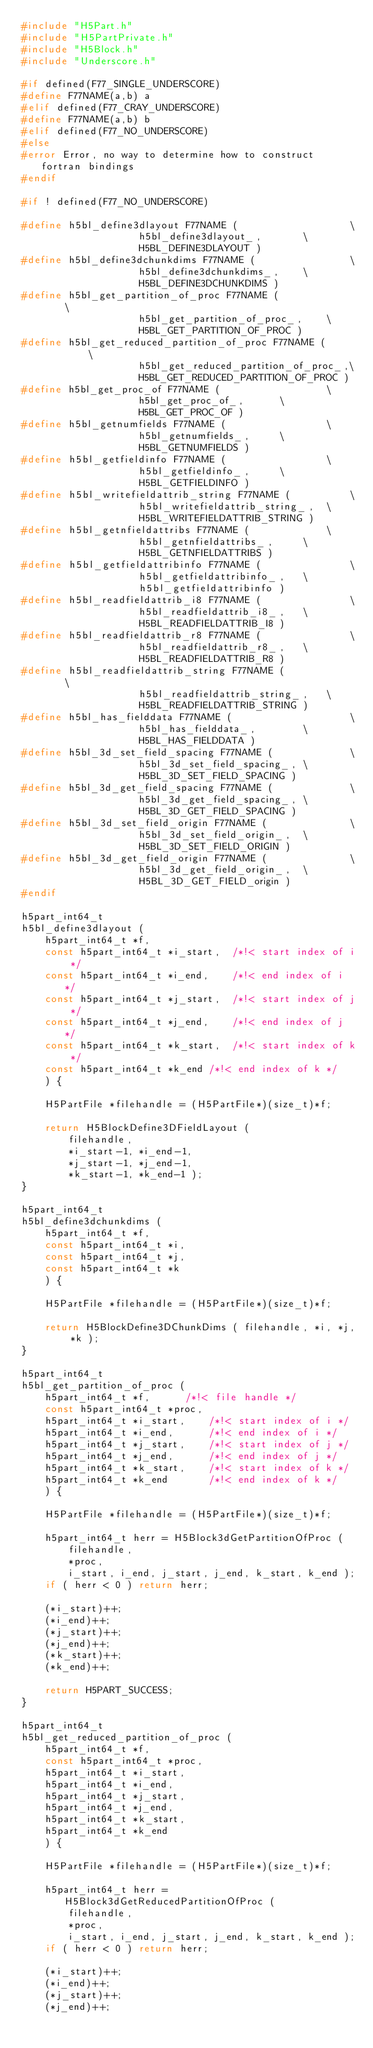<code> <loc_0><loc_0><loc_500><loc_500><_C_>#include "H5Part.h"
#include "H5PartPrivate.h"
#include "H5Block.h"
#include "Underscore.h"

#if defined(F77_SINGLE_UNDERSCORE)
#define F77NAME(a,b) a
#elif defined(F77_CRAY_UNDERSCORE)
#define F77NAME(a,b) b
#elif defined(F77_NO_UNDERSCORE)
#else
#error Error, no way to determine how to construct fortran bindings
#endif

#if ! defined(F77_NO_UNDERSCORE)

#define h5bl_define3dlayout F77NAME (					\
					h5bl_define3dlayout_,		\
					H5BL_DEFINE3DLAYOUT )
#define h5bl_define3dchunkdims F77NAME (				\
					h5bl_define3dchunkdims_,	\
					H5BL_DEFINE3DCHUNKDIMS )
#define h5bl_get_partition_of_proc F77NAME (				\
					h5bl_get_partition_of_proc_,	\
					H5BL_GET_PARTITION_OF_PROC )
#define h5bl_get_reduced_partition_of_proc F77NAME (			\
					h5bl_get_reduced_partition_of_proc_,\
					H5BL_GET_REDUCED_PARTITION_OF_PROC )
#define h5bl_get_proc_of F77NAME (					\
					h5bl_get_proc_of_,		\
					H5BL_GET_PROC_OF )
#define h5bl_getnumfields F77NAME (					\
					h5bl_getnumfields_,		\
					H5BL_GETNUMFIELDS )
#define h5bl_getfieldinfo F77NAME (					\
					h5bl_getfieldinfo_,		\
					H5BL_GETFIELDINFO )
#define h5bl_writefieldattrib_string F77NAME (			\
					h5bl_writefieldattrib_string_,	\
					H5BL_WRITEFIELDATTRIB_STRING )
#define h5bl_getnfieldattribs F77NAME (				\
					h5bl_getnfieldattribs_,		\
					H5BL_GETNFIELDATTRIBS )
#define h5bl_getfieldattribinfo F77NAME (				\
					h5bl_getfieldattribinfo_,	\
					h5bl_getfieldattribinfo )
#define h5bl_readfieldattrib_i8 F77NAME (				\
					h5bl_readfieldattrib_i8_,	\
					H5BL_READFIELDATTRIB_I8 )
#define h5bl_readfieldattrib_r8 F77NAME (				\
					h5bl_readfieldattrib_r8_,	\
					H5BL_READFIELDATTRIB_R8 )
#define h5bl_readfieldattrib_string F77NAME (				\
					h5bl_readfieldattrib_string_,	\
					H5BL_READFIELDATTRIB_STRING )
#define h5bl_has_fielddata F77NAME (					\
					h5bl_has_fielddata_,		\
					H5BL_HAS_FIELDDATA )
#define h5bl_3d_set_field_spacing F77NAME (				\
					h5bl_3d_set_field_spacing_,	\
					H5BL_3D_SET_FIELD_SPACING )
#define h5bl_3d_get_field_spacing F77NAME (				\
					h5bl_3d_get_field_spacing_,	\
					H5BL_3D_GET_FIELD_SPACING )
#define h5bl_3d_set_field_origin F77NAME (				\
					h5bl_3d_set_field_origin_,	\
					H5BL_3D_SET_FIELD_ORIGIN )
#define h5bl_3d_get_field_origin F77NAME (				\
					h5bl_3d_get_field_origin_,	\
					H5BL_3D_GET_FIELD_origin )
#endif

h5part_int64_t
h5bl_define3dlayout (
	h5part_int64_t *f,
	const h5part_int64_t *i_start,	/*!< start index of i */
	const h5part_int64_t *i_end,	/*!< end index of i */
	const h5part_int64_t *j_start,	/*!< start index of j */
	const h5part_int64_t *j_end,	/*!< end index of j */
	const h5part_int64_t *k_start,	/*!< start index of k */
	const h5part_int64_t *k_end	/*!< end index of k */
	) {

	H5PartFile *filehandle = (H5PartFile*)(size_t)*f;

	return H5BlockDefine3DFieldLayout (
		filehandle,
		*i_start-1, *i_end-1,
		*j_start-1, *j_end-1,
		*k_start-1, *k_end-1 );
}

h5part_int64_t
h5bl_define3dchunkdims (
	h5part_int64_t *f,
	const h5part_int64_t *i,
	const h5part_int64_t *j,
	const h5part_int64_t *k
	) {

	H5PartFile *filehandle = (H5PartFile*)(size_t)*f;

	return H5BlockDefine3DChunkDims ( filehandle, *i, *j, *k );
}

h5part_int64_t
h5bl_get_partition_of_proc (
	h5part_int64_t *f,		/*!< file handle */
	const h5part_int64_t *proc,
	h5part_int64_t *i_start,	/*!< start index of i */
	h5part_int64_t *i_end,		/*!< end index of i */
	h5part_int64_t *j_start,	/*!< start index of j */
	h5part_int64_t *j_end,		/*!< end index of j */
	h5part_int64_t *k_start,	/*!< start index of k */
	h5part_int64_t *k_end		/*!< end index of k */
	) {

	H5PartFile *filehandle = (H5PartFile*)(size_t)*f;

	h5part_int64_t herr = H5Block3dGetPartitionOfProc (
		filehandle,
		*proc,
		i_start, i_end, j_start, j_end, k_start, k_end );
	if ( herr < 0 ) return herr;

	(*i_start)++;
	(*i_end)++;
	(*j_start)++;
	(*j_end)++;
	(*k_start)++;
	(*k_end)++;

	return H5PART_SUCCESS;
}

h5part_int64_t
h5bl_get_reduced_partition_of_proc (
	h5part_int64_t *f,
	const h5part_int64_t *proc,
	h5part_int64_t *i_start, 
	h5part_int64_t *i_end,
	h5part_int64_t *j_start,
	h5part_int64_t *j_end,
	h5part_int64_t *k_start,
	h5part_int64_t *k_end
	) {

	H5PartFile *filehandle = (H5PartFile*)(size_t)*f;

	h5part_int64_t herr = H5Block3dGetReducedPartitionOfProc (
		filehandle,
		*proc,
		i_start, i_end, j_start, j_end, k_start, k_end );
	if ( herr < 0 ) return herr;

	(*i_start)++;
	(*i_end)++;
	(*j_start)++;
	(*j_end)++;</code> 